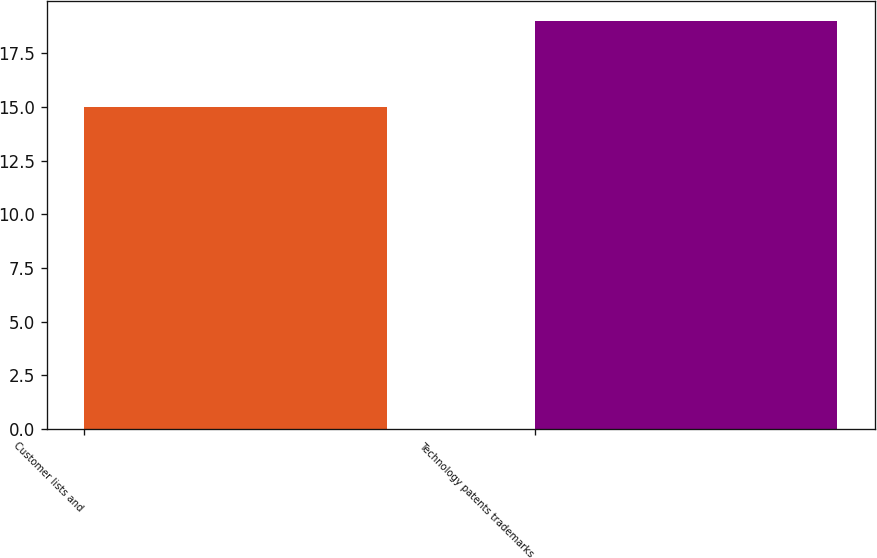Convert chart to OTSL. <chart><loc_0><loc_0><loc_500><loc_500><bar_chart><fcel>Customer lists and<fcel>Technology patents trademarks<nl><fcel>15<fcel>19<nl></chart> 